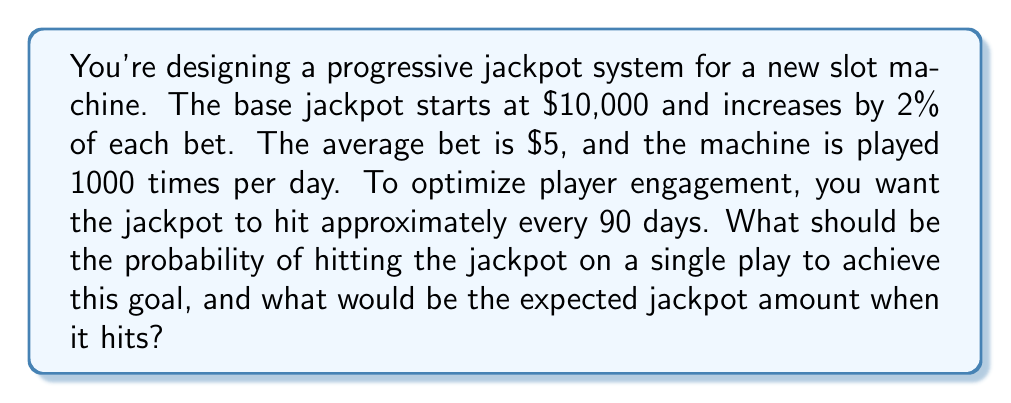Could you help me with this problem? Let's approach this step-by-step:

1) First, we need to calculate how many plays occur in 90 days:
   $$ \text{Plays in 90 days} = 1000 \text{ plays/day} \times 90 \text{ days} = 90,000 \text{ plays} $$

2) The probability of hitting the jackpot should be such that it's expected to hit once in these 90,000 plays. Therefore:
   $$ P(\text{hit}) = \frac{1}{90,000} \approx 0.0000111 $$

3) Now, let's calculate the expected jackpot amount when it hits. We need to find how much the jackpot increases per day:
   $$ \text{Daily increase} = 1000 \text{ plays} \times $5 \text{ per play} \times 2\% = $100 \text{ per day} $$

4) Over 90 days, the jackpot increase would be:
   $$ \text{Total increase} = $100 \text{ per day} \times 90 \text{ days} = $9,000 $$

5) Therefore, the expected jackpot when it hits would be:
   $$ \text{Expected jackpot} = $10,000 \text{ (base)} + $9,000 \text{ (increase)} = $19,000 $$

This structure balances player engagement (with a sizable jackpot that grows visibly over time) and casino profitability (by controlling the hit frequency and payout size).
Answer: The probability of hitting the jackpot on a single play should be set to approximately $1.11 \times 10^{-5}$ or $0.0000111$, and the expected jackpot amount when it hits would be $19,000. 